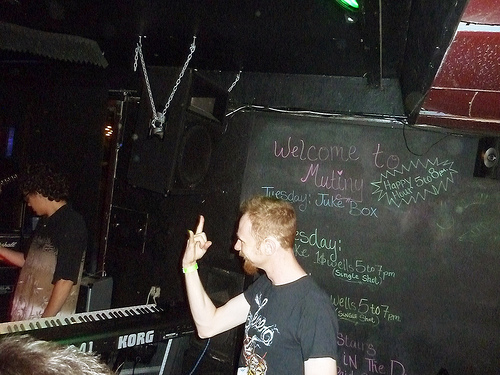<image>
Can you confirm if the keyboard is under the sound box? Yes. The keyboard is positioned underneath the sound box, with the sound box above it in the vertical space. 